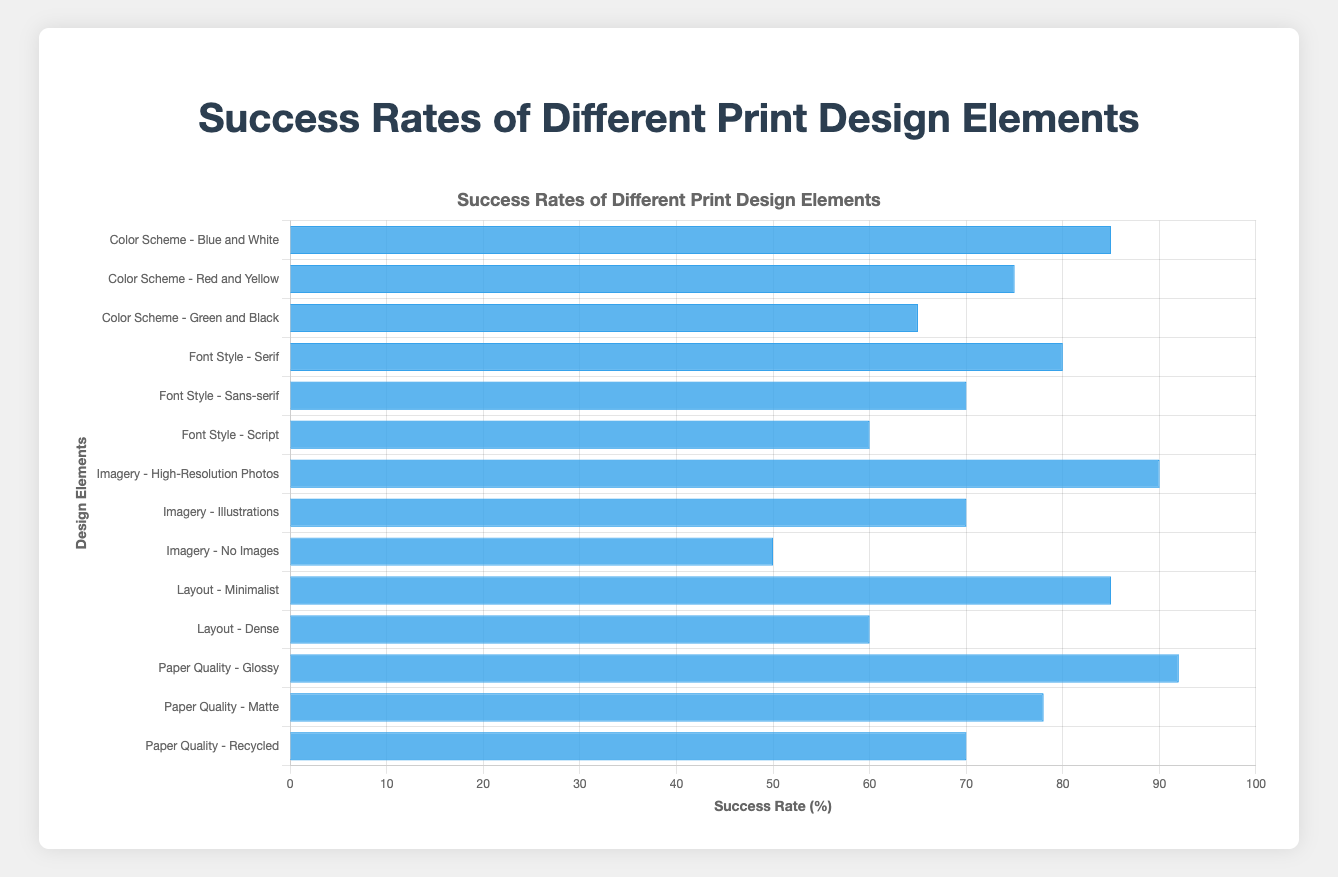What print design element has the highest success rate? The bar chart indicates the heights of the bars for each design element, and the bar for "Paper Quality - Glossy" is the highest, reaching a 92% success rate.
Answer: Paper Quality - Glossy Which font style has a higher success rate, Serif or Sans-serif? By comparing the heights of the bars labeled "Font Style - Serif" and "Font Style - Sans-serif," the bar for "Serif" is taller, indicating an 80% success rate, whereas "Sans-serif" has a 70% success rate.
Answer: Serif What is the difference in success rates between "Color Scheme - Blue and White" and "Imagery - No Images"? The "Color Scheme - Blue and White" has a success rate of 85%, and "Imagery - No Images" has 50%. By subtracting these values, the difference is 85% - 50% = 35%.
Answer: 35% Which print design element has the lowest success rate? The bar labeled "Imagery - No Images" is the shortest, indicating a 50% success rate, which is the lowest among all elements.
Answer: Imagery - No Images What is the average success rate of the different font styles? The font styles are Serif, Sans-serif, and Script with success rates of 80%, 70%, and 60%, respectively. Adding these rates (80 + 70 + 60 = 210) and dividing by the number of styles (3) gives the average: 210 / 3 = 70%.
Answer: 70% How does the success rate of "Layout - Minimalist" compare to "Layout - Dense"? The bar for "Layout - Minimalist" shows an 85% success rate, whereas "Layout - Dense" shows a 60% success rate. Minimalist is higher.
Answer: Minimalist is higher What is the combined success rate of all "Color Scheme" elements? The success rates for the "Color Scheme" elements are 85% (Blue and White), 75% (Red and Yellow), and 65% (Green and Black). Their sum is 85 + 75 + 65 = 225%.
Answer: 225% Which element type (Color Scheme, Font Style, Imagery, Layout, Paper Quality) has the most elements in the chart? By counting the number of bars associated with each type: Color Scheme has 3 elements, Font Style has 3, Imagery has 3, Layout has 2, and Paper Quality has 3. All have equal representation except Layout.
Answer: Color Scheme, Font Style, Imagery, and Paper Quality What is the difference in success rate between the highest-rated and lowest-rated Imagery elements? The highest-rated Imagery element is "High-Resolution Photos" with 90% and the lowest is "No Images" with 50%. The difference is 90% - 50% = 40%.
Answer: 40% What is the average success rate of all the layout elements? The Layout elements are Minimalist and Dense with success rates of 85% and 60%, respectively. Their average is (85 + 60) / 2 = 145 / 2 = 72.5%.
Answer: 72.5% 